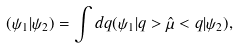<formula> <loc_0><loc_0><loc_500><loc_500>( \psi _ { 1 } | \psi _ { 2 } ) = \int d q ( \psi _ { 1 } | q > \hat { \mu } < q | \psi _ { 2 } ) ,</formula> 